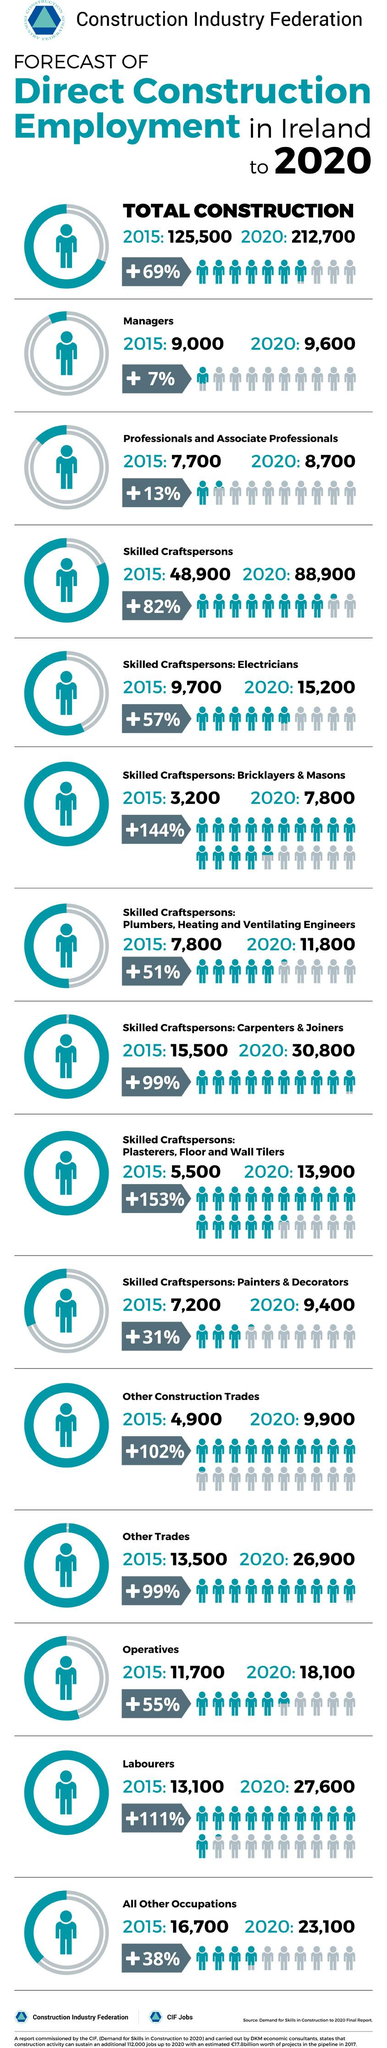Draw attention to some important aspects in this diagram. By 2020, it is estimated that there will be a significant increase of 82% in the number of skilled craftspersons in Ireland. The estimated percentage increase of laborers in Ireland by 2020 is projected to be +111%. In 2015, there were approximately 15,500 carpenters and joiners employed in Ireland. In 2015, there were approximately 7,200 painters and decorators employed in Ireland. It is estimated that by 2020, approximately 15,200 electricians will be employed in Ireland. 